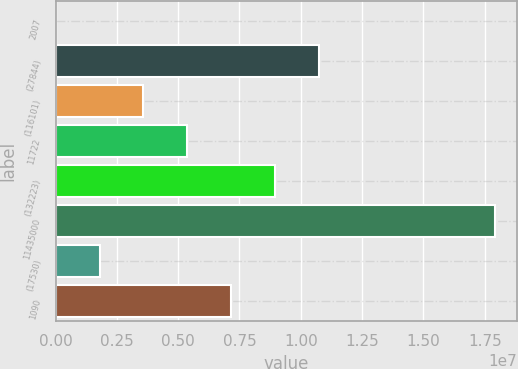Convert chart. <chart><loc_0><loc_0><loc_500><loc_500><bar_chart><fcel>2007<fcel>(27844)<fcel>(116101)<fcel>11722<fcel>(132223)<fcel>11435000<fcel>(17530)<fcel>1090<nl><fcel>2005<fcel>1.07528e+07<fcel>3.5856e+06<fcel>5.3774e+06<fcel>8.961e+06<fcel>1.792e+07<fcel>1.7938e+06<fcel>7.1692e+06<nl></chart> 